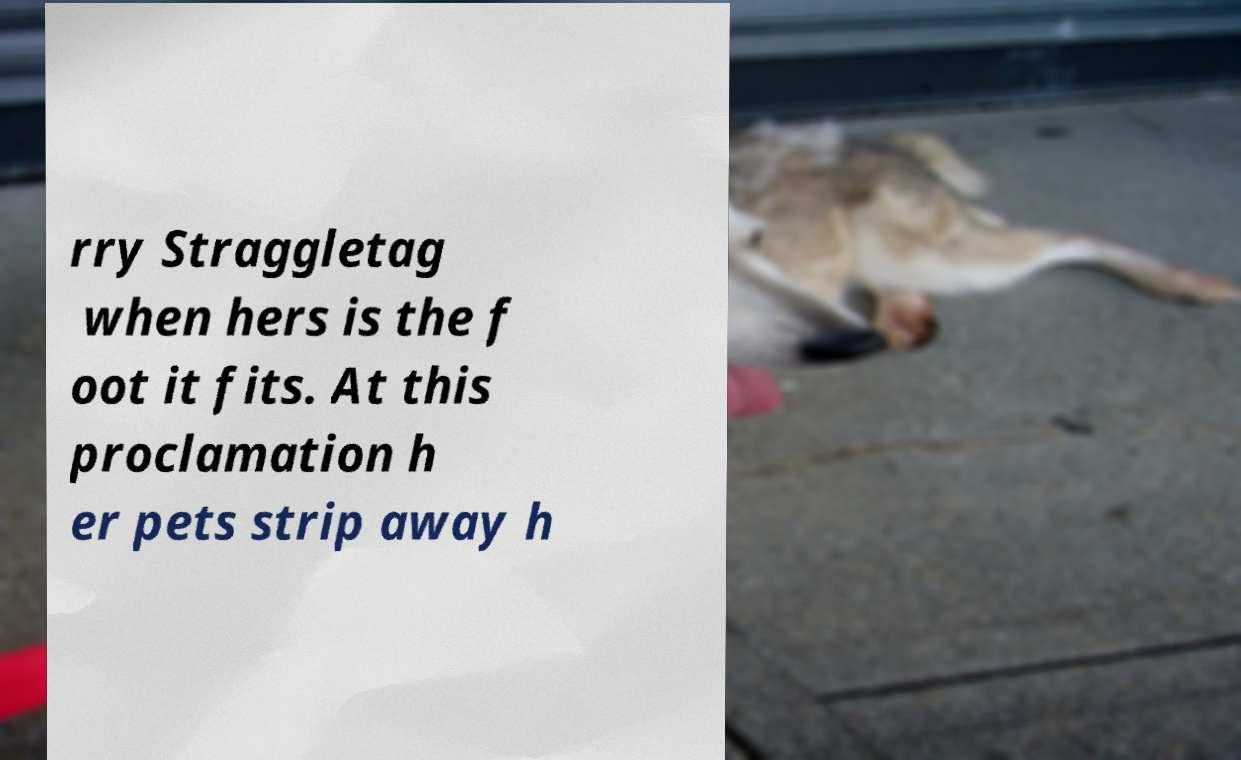I need the written content from this picture converted into text. Can you do that? rry Straggletag when hers is the f oot it fits. At this proclamation h er pets strip away h 